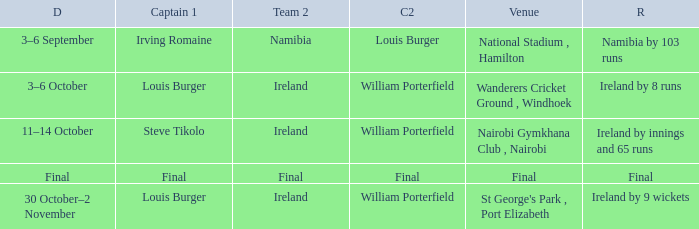Which Captain 2 has a Result of ireland by 8 runs? William Porterfield. 